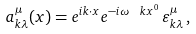Convert formula to latex. <formula><loc_0><loc_0><loc_500><loc_500>a ^ { \mu } _ { k \lambda } ( x ) = e ^ { i k \cdot x } e ^ { - i \omega _ { \ } k x ^ { 0 } } \, \varepsilon ^ { \mu } _ { k \lambda } \, ,</formula> 